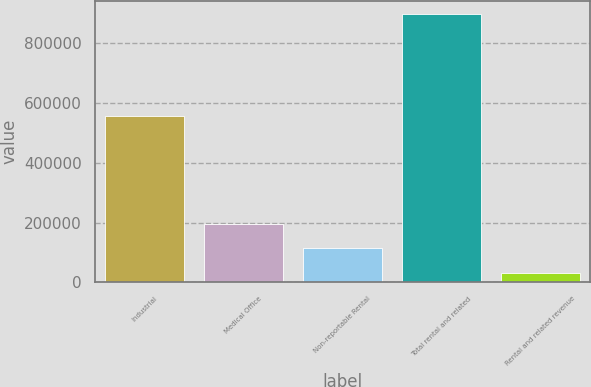<chart> <loc_0><loc_0><loc_500><loc_500><bar_chart><fcel>Industrial<fcel>Medical Office<fcel>Non-reportable Rental<fcel>Total rental and related<fcel>Rental and related revenue<nl><fcel>556903<fcel>195762<fcel>114156<fcel>897672<fcel>32549<nl></chart> 